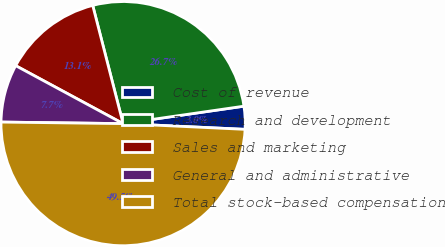Convert chart. <chart><loc_0><loc_0><loc_500><loc_500><pie_chart><fcel>Cost of revenue<fcel>Research and development<fcel>Sales and marketing<fcel>General and administrative<fcel>Total stock-based compensation<nl><fcel>3.03%<fcel>26.72%<fcel>13.12%<fcel>7.67%<fcel>49.45%<nl></chart> 